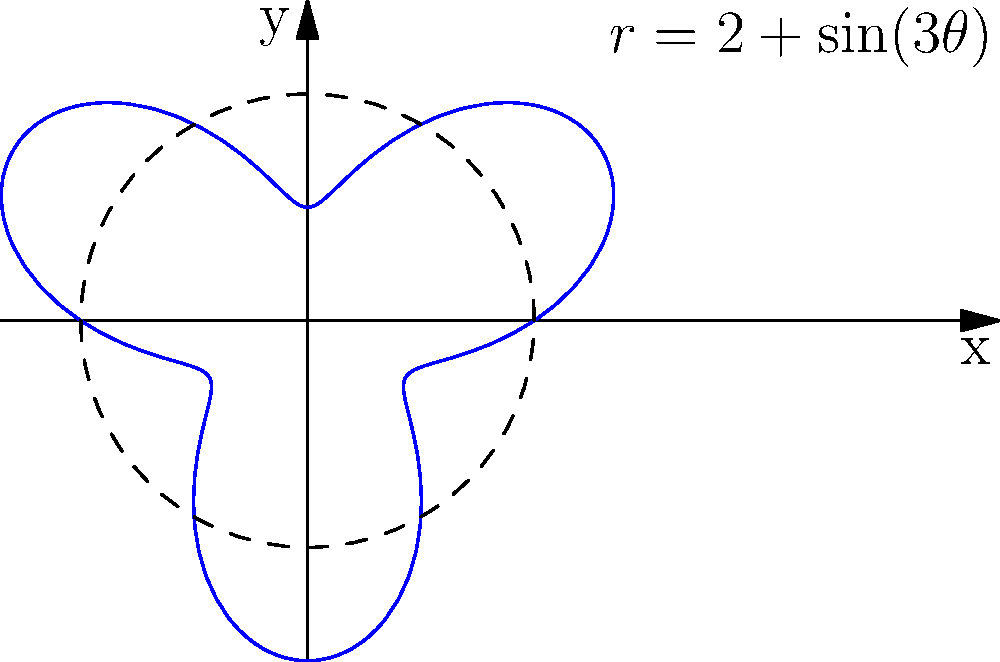As a stage manager, you're designing an irregularly shaped set piece for a new production. The shape of the piece can be described in polar coordinates by the equation $r = 2 + \sin(3\theta)$, where $r$ is in meters. What is the area of this set piece in square meters? To calculate the area of this irregularly shaped stage set piece, we'll use polar integration. Here's the step-by-step process:

1) The formula for the area of a region in polar coordinates is:

   $$A = \frac{1}{2} \int_0^{2\pi} r^2(\theta) d\theta$$

2) In this case, $r(\theta) = 2 + \sin(3\theta)$. We need to square this:

   $$r^2(\theta) = (2 + \sin(3\theta))^2 = 4 + 4\sin(3\theta) + \sin^2(3\theta)$$

3) Now, let's set up the integral:

   $$A = \frac{1}{2} \int_0^{2\pi} (4 + 4\sin(3\theta) + \sin^2(3\theta)) d\theta$$

4) Let's integrate each term separately:

   a) $\int_0^{2\pi} 4 d\theta = 4\theta \big|_0^{2\pi} = 8\pi$

   b) $\int_0^{2\pi} 4\sin(3\theta) d\theta = -\frac{4}{3}\cos(3\theta) \big|_0^{2\pi} = 0$

   c) $\int_0^{2\pi} \sin^2(3\theta) d\theta = \int_0^{2\pi} \frac{1 - \cos(6\theta)}{2} d\theta = \frac{\theta}{2} - \frac{\sin(6\theta)}{12} \big|_0^{2\pi} = \pi$

5) Adding these up and multiplying by $\frac{1}{2}$:

   $$A = \frac{1}{2}(8\pi + 0 + \pi) = \frac{9\pi}{2} \approx 14.14 \text{ m}^2$$

Therefore, the area of the set piece is $\frac{9\pi}{2}$ square meters.
Answer: $\frac{9\pi}{2}$ m² 